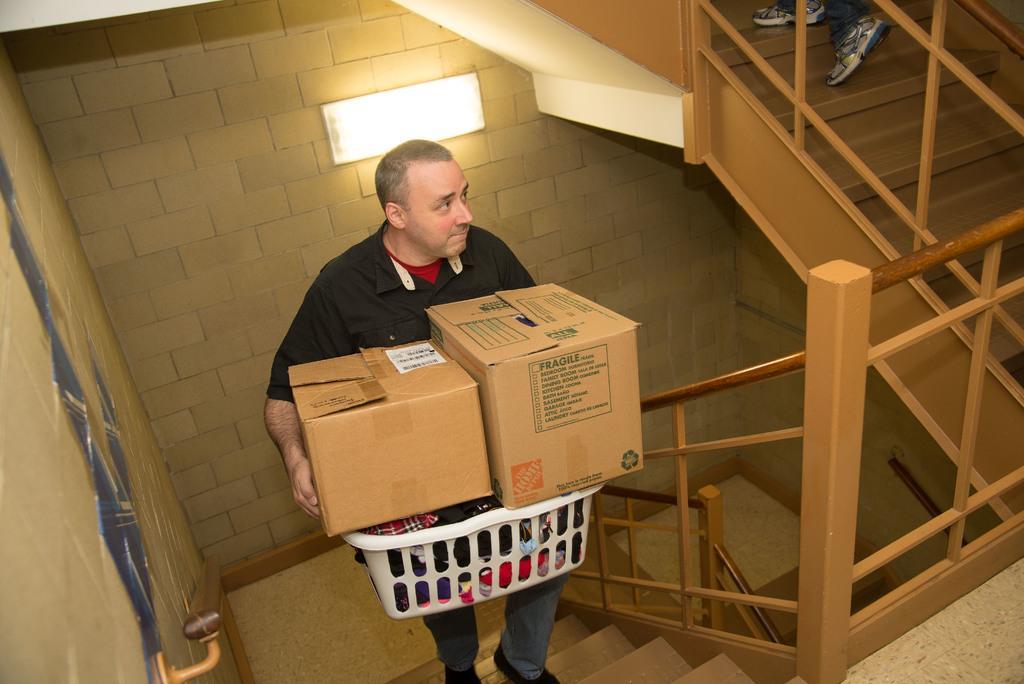Could you give a brief overview of what you see in this image? In this image we can see a man holding the basket with the clothes and also the cardboard boxes. We can also see the stairs, railing, path, walls and also the light. We can also see some person's legs. 